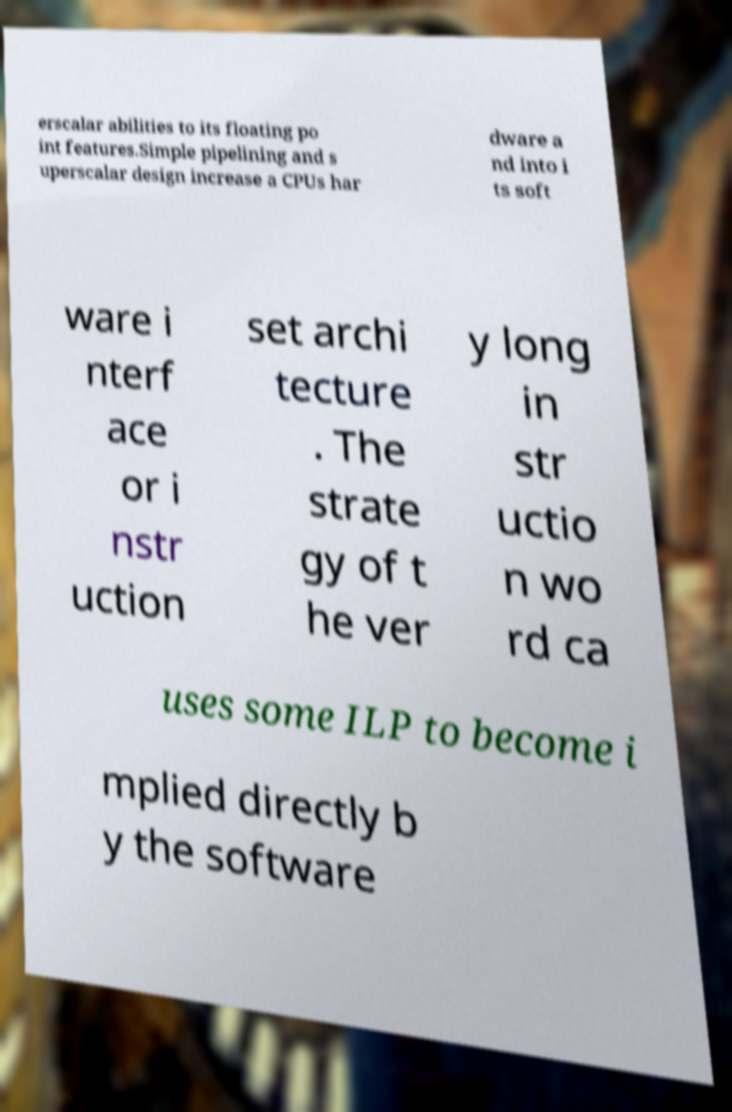Can you accurately transcribe the text from the provided image for me? erscalar abilities to its floating po int features.Simple pipelining and s uperscalar design increase a CPUs har dware a nd into i ts soft ware i nterf ace or i nstr uction set archi tecture . The strate gy of t he ver y long in str uctio n wo rd ca uses some ILP to become i mplied directly b y the software 